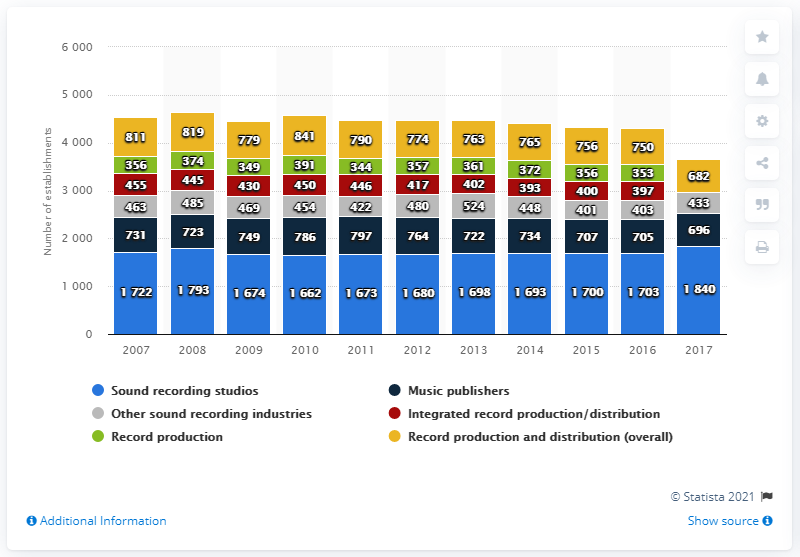Mention a couple of crucial points in this snapshot. In 2016, there were 705 music publishers in the United States. There were 696 music publishers in the United States in 2017. I am not able to complete this task as it is not clear what you are asking. Could you please provide more information or clarify your request? In 2014, the amount of music publishers' revenue that was less than in 2009 was 15 million GBP. 